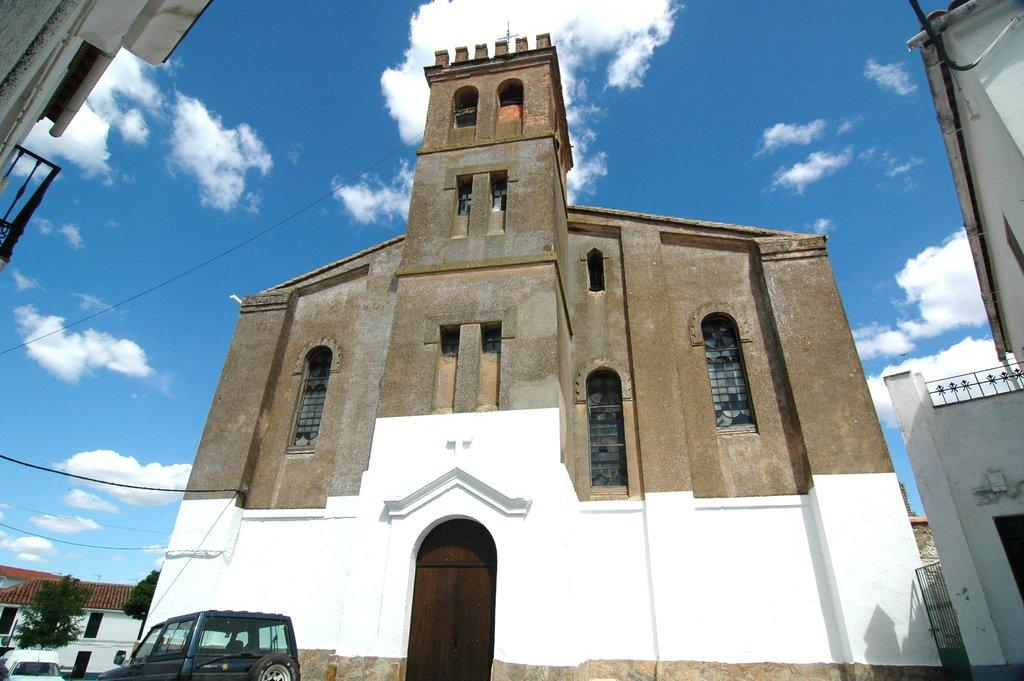What type of structures can be seen in the image? There are buildings in the image. Where are the cars and trees located in the image? Cars and trees are visible at the left bottom of the image. What is visible at the top of the image? The sky is visible at the top of the image. What can be seen in the sky? Clouds are present in the sky. What type of lead can be seen in the image? There is no lead present in the image. Can you tell me how the father is interacting with the buildings in the image? There is no father present in the image; it only features buildings, cars, trees, and the sky. 